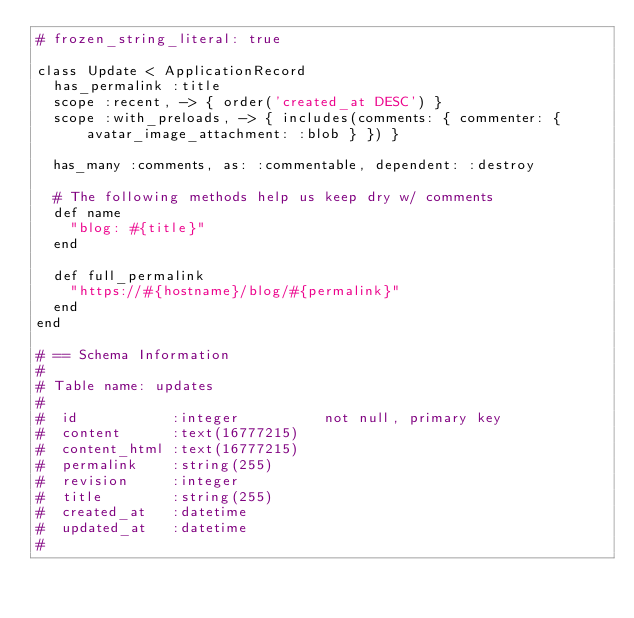<code> <loc_0><loc_0><loc_500><loc_500><_Ruby_># frozen_string_literal: true

class Update < ApplicationRecord
  has_permalink :title
  scope :recent, -> { order('created_at DESC') }
  scope :with_preloads, -> { includes(comments: { commenter: { avatar_image_attachment: :blob } }) }

  has_many :comments, as: :commentable, dependent: :destroy

  # The following methods help us keep dry w/ comments
  def name
    "blog: #{title}"
  end

  def full_permalink
    "https://#{hostname}/blog/#{permalink}"
  end
end

# == Schema Information
#
# Table name: updates
#
#  id           :integer          not null, primary key
#  content      :text(16777215)
#  content_html :text(16777215)
#  permalink    :string(255)
#  revision     :integer
#  title        :string(255)
#  created_at   :datetime
#  updated_at   :datetime
#
</code> 